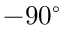<formula> <loc_0><loc_0><loc_500><loc_500>- 9 0 ^ { \circ }</formula> 